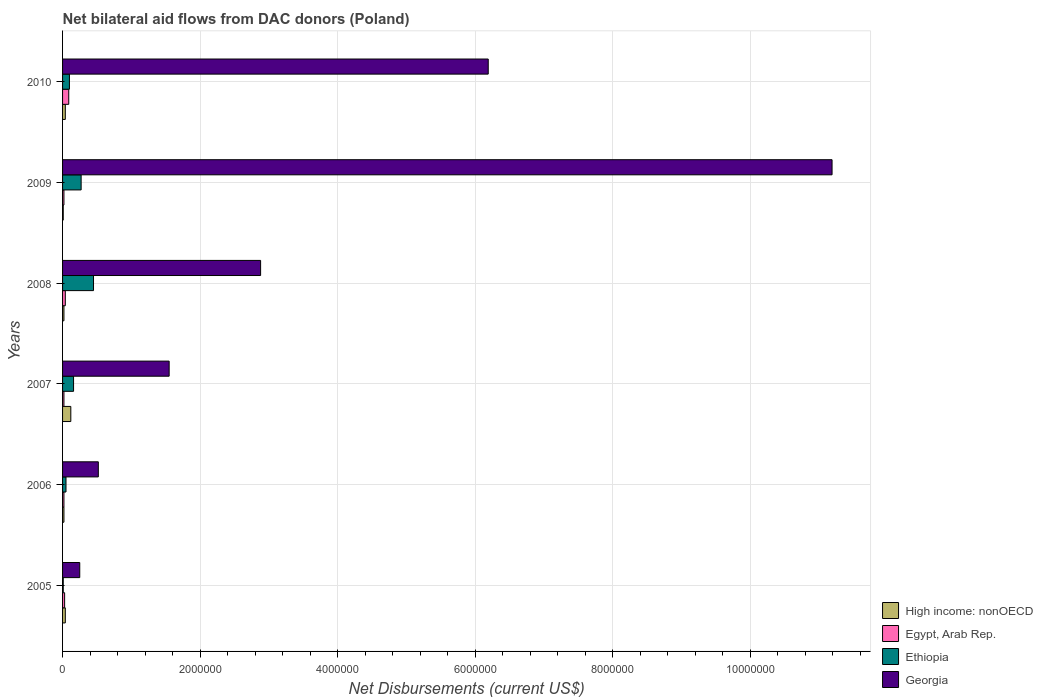How many different coloured bars are there?
Provide a short and direct response. 4. How many groups of bars are there?
Your answer should be very brief. 6. Are the number of bars on each tick of the Y-axis equal?
Your answer should be very brief. Yes. How many bars are there on the 1st tick from the bottom?
Provide a short and direct response. 4. What is the net bilateral aid flows in High income: nonOECD in 2007?
Provide a succinct answer. 1.20e+05. Across all years, what is the maximum net bilateral aid flows in Egypt, Arab Rep.?
Provide a succinct answer. 9.00e+04. Across all years, what is the minimum net bilateral aid flows in Egypt, Arab Rep.?
Offer a very short reply. 2.00e+04. In which year was the net bilateral aid flows in Egypt, Arab Rep. maximum?
Provide a short and direct response. 2010. What is the total net bilateral aid flows in High income: nonOECD in the graph?
Ensure brevity in your answer.  2.50e+05. What is the difference between the net bilateral aid flows in High income: nonOECD in 2009 and the net bilateral aid flows in Georgia in 2007?
Give a very brief answer. -1.54e+06. What is the average net bilateral aid flows in Ethiopia per year?
Ensure brevity in your answer.  1.73e+05. In the year 2009, what is the difference between the net bilateral aid flows in Ethiopia and net bilateral aid flows in High income: nonOECD?
Provide a succinct answer. 2.60e+05. What is the ratio of the net bilateral aid flows in Egypt, Arab Rep. in 2005 to that in 2007?
Your response must be concise. 1.5. What is the difference between the highest and the lowest net bilateral aid flows in Georgia?
Provide a short and direct response. 1.09e+07. In how many years, is the net bilateral aid flows in Georgia greater than the average net bilateral aid flows in Georgia taken over all years?
Offer a terse response. 2. Is it the case that in every year, the sum of the net bilateral aid flows in Ethiopia and net bilateral aid flows in Georgia is greater than the sum of net bilateral aid flows in Egypt, Arab Rep. and net bilateral aid flows in High income: nonOECD?
Your answer should be compact. Yes. What does the 1st bar from the top in 2007 represents?
Keep it short and to the point. Georgia. What does the 4th bar from the bottom in 2010 represents?
Offer a terse response. Georgia. How many bars are there?
Your answer should be very brief. 24. Are all the bars in the graph horizontal?
Your answer should be very brief. Yes. Are the values on the major ticks of X-axis written in scientific E-notation?
Your answer should be compact. No. Does the graph contain any zero values?
Give a very brief answer. No. Does the graph contain grids?
Make the answer very short. Yes. What is the title of the graph?
Keep it short and to the point. Net bilateral aid flows from DAC donors (Poland). Does "Faeroe Islands" appear as one of the legend labels in the graph?
Your answer should be compact. No. What is the label or title of the X-axis?
Make the answer very short. Net Disbursements (current US$). What is the label or title of the Y-axis?
Offer a very short reply. Years. What is the Net Disbursements (current US$) in Georgia in 2005?
Give a very brief answer. 2.50e+05. What is the Net Disbursements (current US$) in High income: nonOECD in 2006?
Your answer should be very brief. 2.00e+04. What is the Net Disbursements (current US$) of Ethiopia in 2006?
Keep it short and to the point. 5.00e+04. What is the Net Disbursements (current US$) of Georgia in 2006?
Give a very brief answer. 5.20e+05. What is the Net Disbursements (current US$) of High income: nonOECD in 2007?
Provide a succinct answer. 1.20e+05. What is the Net Disbursements (current US$) in Ethiopia in 2007?
Provide a succinct answer. 1.60e+05. What is the Net Disbursements (current US$) in Georgia in 2007?
Offer a terse response. 1.55e+06. What is the Net Disbursements (current US$) in Ethiopia in 2008?
Your response must be concise. 4.50e+05. What is the Net Disbursements (current US$) in Georgia in 2008?
Keep it short and to the point. 2.88e+06. What is the Net Disbursements (current US$) of High income: nonOECD in 2009?
Your answer should be very brief. 10000. What is the Net Disbursements (current US$) of Egypt, Arab Rep. in 2009?
Your response must be concise. 2.00e+04. What is the Net Disbursements (current US$) in Georgia in 2009?
Your answer should be very brief. 1.12e+07. What is the Net Disbursements (current US$) of Ethiopia in 2010?
Provide a short and direct response. 1.00e+05. What is the Net Disbursements (current US$) in Georgia in 2010?
Ensure brevity in your answer.  6.19e+06. Across all years, what is the maximum Net Disbursements (current US$) of Egypt, Arab Rep.?
Your answer should be compact. 9.00e+04. Across all years, what is the maximum Net Disbursements (current US$) of Georgia?
Provide a short and direct response. 1.12e+07. Across all years, what is the minimum Net Disbursements (current US$) of High income: nonOECD?
Offer a very short reply. 10000. Across all years, what is the minimum Net Disbursements (current US$) in Ethiopia?
Your answer should be very brief. 10000. Across all years, what is the minimum Net Disbursements (current US$) in Georgia?
Ensure brevity in your answer.  2.50e+05. What is the total Net Disbursements (current US$) of High income: nonOECD in the graph?
Provide a short and direct response. 2.50e+05. What is the total Net Disbursements (current US$) of Egypt, Arab Rep. in the graph?
Your response must be concise. 2.20e+05. What is the total Net Disbursements (current US$) of Ethiopia in the graph?
Make the answer very short. 1.04e+06. What is the total Net Disbursements (current US$) in Georgia in the graph?
Offer a very short reply. 2.26e+07. What is the difference between the Net Disbursements (current US$) of High income: nonOECD in 2005 and that in 2006?
Keep it short and to the point. 2.00e+04. What is the difference between the Net Disbursements (current US$) of Georgia in 2005 and that in 2006?
Give a very brief answer. -2.70e+05. What is the difference between the Net Disbursements (current US$) in High income: nonOECD in 2005 and that in 2007?
Give a very brief answer. -8.00e+04. What is the difference between the Net Disbursements (current US$) of Egypt, Arab Rep. in 2005 and that in 2007?
Provide a succinct answer. 10000. What is the difference between the Net Disbursements (current US$) in Georgia in 2005 and that in 2007?
Ensure brevity in your answer.  -1.30e+06. What is the difference between the Net Disbursements (current US$) of High income: nonOECD in 2005 and that in 2008?
Keep it short and to the point. 2.00e+04. What is the difference between the Net Disbursements (current US$) of Egypt, Arab Rep. in 2005 and that in 2008?
Your answer should be very brief. -10000. What is the difference between the Net Disbursements (current US$) of Ethiopia in 2005 and that in 2008?
Your answer should be very brief. -4.40e+05. What is the difference between the Net Disbursements (current US$) of Georgia in 2005 and that in 2008?
Make the answer very short. -2.63e+06. What is the difference between the Net Disbursements (current US$) in Ethiopia in 2005 and that in 2009?
Offer a terse response. -2.60e+05. What is the difference between the Net Disbursements (current US$) of Georgia in 2005 and that in 2009?
Offer a very short reply. -1.09e+07. What is the difference between the Net Disbursements (current US$) in High income: nonOECD in 2005 and that in 2010?
Your answer should be compact. 0. What is the difference between the Net Disbursements (current US$) in Georgia in 2005 and that in 2010?
Your answer should be compact. -5.94e+06. What is the difference between the Net Disbursements (current US$) in Georgia in 2006 and that in 2007?
Offer a very short reply. -1.03e+06. What is the difference between the Net Disbursements (current US$) of Ethiopia in 2006 and that in 2008?
Offer a terse response. -4.00e+05. What is the difference between the Net Disbursements (current US$) in Georgia in 2006 and that in 2008?
Your answer should be very brief. -2.36e+06. What is the difference between the Net Disbursements (current US$) in Egypt, Arab Rep. in 2006 and that in 2009?
Your answer should be compact. 0. What is the difference between the Net Disbursements (current US$) of Georgia in 2006 and that in 2009?
Ensure brevity in your answer.  -1.07e+07. What is the difference between the Net Disbursements (current US$) of Ethiopia in 2006 and that in 2010?
Provide a succinct answer. -5.00e+04. What is the difference between the Net Disbursements (current US$) in Georgia in 2006 and that in 2010?
Offer a very short reply. -5.67e+06. What is the difference between the Net Disbursements (current US$) in High income: nonOECD in 2007 and that in 2008?
Keep it short and to the point. 1.00e+05. What is the difference between the Net Disbursements (current US$) in Georgia in 2007 and that in 2008?
Ensure brevity in your answer.  -1.33e+06. What is the difference between the Net Disbursements (current US$) of High income: nonOECD in 2007 and that in 2009?
Offer a terse response. 1.10e+05. What is the difference between the Net Disbursements (current US$) of Egypt, Arab Rep. in 2007 and that in 2009?
Your answer should be very brief. 0. What is the difference between the Net Disbursements (current US$) in Ethiopia in 2007 and that in 2009?
Provide a short and direct response. -1.10e+05. What is the difference between the Net Disbursements (current US$) in Georgia in 2007 and that in 2009?
Ensure brevity in your answer.  -9.64e+06. What is the difference between the Net Disbursements (current US$) in High income: nonOECD in 2007 and that in 2010?
Your answer should be compact. 8.00e+04. What is the difference between the Net Disbursements (current US$) of Egypt, Arab Rep. in 2007 and that in 2010?
Keep it short and to the point. -7.00e+04. What is the difference between the Net Disbursements (current US$) in Georgia in 2007 and that in 2010?
Your response must be concise. -4.64e+06. What is the difference between the Net Disbursements (current US$) in Ethiopia in 2008 and that in 2009?
Your answer should be very brief. 1.80e+05. What is the difference between the Net Disbursements (current US$) of Georgia in 2008 and that in 2009?
Your answer should be compact. -8.31e+06. What is the difference between the Net Disbursements (current US$) of High income: nonOECD in 2008 and that in 2010?
Make the answer very short. -2.00e+04. What is the difference between the Net Disbursements (current US$) of Egypt, Arab Rep. in 2008 and that in 2010?
Your response must be concise. -5.00e+04. What is the difference between the Net Disbursements (current US$) in Ethiopia in 2008 and that in 2010?
Offer a terse response. 3.50e+05. What is the difference between the Net Disbursements (current US$) in Georgia in 2008 and that in 2010?
Give a very brief answer. -3.31e+06. What is the difference between the Net Disbursements (current US$) in Ethiopia in 2009 and that in 2010?
Your answer should be very brief. 1.70e+05. What is the difference between the Net Disbursements (current US$) of High income: nonOECD in 2005 and the Net Disbursements (current US$) of Ethiopia in 2006?
Offer a very short reply. -10000. What is the difference between the Net Disbursements (current US$) in High income: nonOECD in 2005 and the Net Disbursements (current US$) in Georgia in 2006?
Provide a short and direct response. -4.80e+05. What is the difference between the Net Disbursements (current US$) in Egypt, Arab Rep. in 2005 and the Net Disbursements (current US$) in Georgia in 2006?
Offer a very short reply. -4.90e+05. What is the difference between the Net Disbursements (current US$) in Ethiopia in 2005 and the Net Disbursements (current US$) in Georgia in 2006?
Your response must be concise. -5.10e+05. What is the difference between the Net Disbursements (current US$) of High income: nonOECD in 2005 and the Net Disbursements (current US$) of Egypt, Arab Rep. in 2007?
Your answer should be very brief. 2.00e+04. What is the difference between the Net Disbursements (current US$) of High income: nonOECD in 2005 and the Net Disbursements (current US$) of Georgia in 2007?
Your answer should be compact. -1.51e+06. What is the difference between the Net Disbursements (current US$) of Egypt, Arab Rep. in 2005 and the Net Disbursements (current US$) of Georgia in 2007?
Your response must be concise. -1.52e+06. What is the difference between the Net Disbursements (current US$) in Ethiopia in 2005 and the Net Disbursements (current US$) in Georgia in 2007?
Make the answer very short. -1.54e+06. What is the difference between the Net Disbursements (current US$) of High income: nonOECD in 2005 and the Net Disbursements (current US$) of Egypt, Arab Rep. in 2008?
Make the answer very short. 0. What is the difference between the Net Disbursements (current US$) of High income: nonOECD in 2005 and the Net Disbursements (current US$) of Ethiopia in 2008?
Your answer should be compact. -4.10e+05. What is the difference between the Net Disbursements (current US$) of High income: nonOECD in 2005 and the Net Disbursements (current US$) of Georgia in 2008?
Keep it short and to the point. -2.84e+06. What is the difference between the Net Disbursements (current US$) of Egypt, Arab Rep. in 2005 and the Net Disbursements (current US$) of Ethiopia in 2008?
Provide a short and direct response. -4.20e+05. What is the difference between the Net Disbursements (current US$) in Egypt, Arab Rep. in 2005 and the Net Disbursements (current US$) in Georgia in 2008?
Give a very brief answer. -2.85e+06. What is the difference between the Net Disbursements (current US$) in Ethiopia in 2005 and the Net Disbursements (current US$) in Georgia in 2008?
Your answer should be compact. -2.87e+06. What is the difference between the Net Disbursements (current US$) of High income: nonOECD in 2005 and the Net Disbursements (current US$) of Ethiopia in 2009?
Your response must be concise. -2.30e+05. What is the difference between the Net Disbursements (current US$) in High income: nonOECD in 2005 and the Net Disbursements (current US$) in Georgia in 2009?
Your response must be concise. -1.12e+07. What is the difference between the Net Disbursements (current US$) of Egypt, Arab Rep. in 2005 and the Net Disbursements (current US$) of Georgia in 2009?
Your answer should be compact. -1.12e+07. What is the difference between the Net Disbursements (current US$) in Ethiopia in 2005 and the Net Disbursements (current US$) in Georgia in 2009?
Your answer should be compact. -1.12e+07. What is the difference between the Net Disbursements (current US$) of High income: nonOECD in 2005 and the Net Disbursements (current US$) of Egypt, Arab Rep. in 2010?
Offer a very short reply. -5.00e+04. What is the difference between the Net Disbursements (current US$) of High income: nonOECD in 2005 and the Net Disbursements (current US$) of Ethiopia in 2010?
Provide a succinct answer. -6.00e+04. What is the difference between the Net Disbursements (current US$) of High income: nonOECD in 2005 and the Net Disbursements (current US$) of Georgia in 2010?
Keep it short and to the point. -6.15e+06. What is the difference between the Net Disbursements (current US$) of Egypt, Arab Rep. in 2005 and the Net Disbursements (current US$) of Ethiopia in 2010?
Provide a short and direct response. -7.00e+04. What is the difference between the Net Disbursements (current US$) in Egypt, Arab Rep. in 2005 and the Net Disbursements (current US$) in Georgia in 2010?
Keep it short and to the point. -6.16e+06. What is the difference between the Net Disbursements (current US$) in Ethiopia in 2005 and the Net Disbursements (current US$) in Georgia in 2010?
Give a very brief answer. -6.18e+06. What is the difference between the Net Disbursements (current US$) of High income: nonOECD in 2006 and the Net Disbursements (current US$) of Egypt, Arab Rep. in 2007?
Make the answer very short. 0. What is the difference between the Net Disbursements (current US$) of High income: nonOECD in 2006 and the Net Disbursements (current US$) of Ethiopia in 2007?
Offer a terse response. -1.40e+05. What is the difference between the Net Disbursements (current US$) in High income: nonOECD in 2006 and the Net Disbursements (current US$) in Georgia in 2007?
Offer a terse response. -1.53e+06. What is the difference between the Net Disbursements (current US$) of Egypt, Arab Rep. in 2006 and the Net Disbursements (current US$) of Ethiopia in 2007?
Offer a very short reply. -1.40e+05. What is the difference between the Net Disbursements (current US$) in Egypt, Arab Rep. in 2006 and the Net Disbursements (current US$) in Georgia in 2007?
Your answer should be compact. -1.53e+06. What is the difference between the Net Disbursements (current US$) of Ethiopia in 2006 and the Net Disbursements (current US$) of Georgia in 2007?
Your response must be concise. -1.50e+06. What is the difference between the Net Disbursements (current US$) of High income: nonOECD in 2006 and the Net Disbursements (current US$) of Ethiopia in 2008?
Your answer should be very brief. -4.30e+05. What is the difference between the Net Disbursements (current US$) of High income: nonOECD in 2006 and the Net Disbursements (current US$) of Georgia in 2008?
Give a very brief answer. -2.86e+06. What is the difference between the Net Disbursements (current US$) in Egypt, Arab Rep. in 2006 and the Net Disbursements (current US$) in Ethiopia in 2008?
Give a very brief answer. -4.30e+05. What is the difference between the Net Disbursements (current US$) in Egypt, Arab Rep. in 2006 and the Net Disbursements (current US$) in Georgia in 2008?
Give a very brief answer. -2.86e+06. What is the difference between the Net Disbursements (current US$) in Ethiopia in 2006 and the Net Disbursements (current US$) in Georgia in 2008?
Give a very brief answer. -2.83e+06. What is the difference between the Net Disbursements (current US$) of High income: nonOECD in 2006 and the Net Disbursements (current US$) of Egypt, Arab Rep. in 2009?
Your answer should be compact. 0. What is the difference between the Net Disbursements (current US$) in High income: nonOECD in 2006 and the Net Disbursements (current US$) in Georgia in 2009?
Offer a very short reply. -1.12e+07. What is the difference between the Net Disbursements (current US$) of Egypt, Arab Rep. in 2006 and the Net Disbursements (current US$) of Ethiopia in 2009?
Provide a succinct answer. -2.50e+05. What is the difference between the Net Disbursements (current US$) in Egypt, Arab Rep. in 2006 and the Net Disbursements (current US$) in Georgia in 2009?
Your response must be concise. -1.12e+07. What is the difference between the Net Disbursements (current US$) of Ethiopia in 2006 and the Net Disbursements (current US$) of Georgia in 2009?
Provide a succinct answer. -1.11e+07. What is the difference between the Net Disbursements (current US$) of High income: nonOECD in 2006 and the Net Disbursements (current US$) of Egypt, Arab Rep. in 2010?
Offer a terse response. -7.00e+04. What is the difference between the Net Disbursements (current US$) of High income: nonOECD in 2006 and the Net Disbursements (current US$) of Georgia in 2010?
Your answer should be very brief. -6.17e+06. What is the difference between the Net Disbursements (current US$) of Egypt, Arab Rep. in 2006 and the Net Disbursements (current US$) of Georgia in 2010?
Keep it short and to the point. -6.17e+06. What is the difference between the Net Disbursements (current US$) of Ethiopia in 2006 and the Net Disbursements (current US$) of Georgia in 2010?
Offer a terse response. -6.14e+06. What is the difference between the Net Disbursements (current US$) in High income: nonOECD in 2007 and the Net Disbursements (current US$) in Ethiopia in 2008?
Provide a succinct answer. -3.30e+05. What is the difference between the Net Disbursements (current US$) in High income: nonOECD in 2007 and the Net Disbursements (current US$) in Georgia in 2008?
Your answer should be very brief. -2.76e+06. What is the difference between the Net Disbursements (current US$) in Egypt, Arab Rep. in 2007 and the Net Disbursements (current US$) in Ethiopia in 2008?
Make the answer very short. -4.30e+05. What is the difference between the Net Disbursements (current US$) of Egypt, Arab Rep. in 2007 and the Net Disbursements (current US$) of Georgia in 2008?
Offer a terse response. -2.86e+06. What is the difference between the Net Disbursements (current US$) of Ethiopia in 2007 and the Net Disbursements (current US$) of Georgia in 2008?
Your answer should be compact. -2.72e+06. What is the difference between the Net Disbursements (current US$) in High income: nonOECD in 2007 and the Net Disbursements (current US$) in Georgia in 2009?
Provide a short and direct response. -1.11e+07. What is the difference between the Net Disbursements (current US$) of Egypt, Arab Rep. in 2007 and the Net Disbursements (current US$) of Ethiopia in 2009?
Give a very brief answer. -2.50e+05. What is the difference between the Net Disbursements (current US$) in Egypt, Arab Rep. in 2007 and the Net Disbursements (current US$) in Georgia in 2009?
Provide a succinct answer. -1.12e+07. What is the difference between the Net Disbursements (current US$) in Ethiopia in 2007 and the Net Disbursements (current US$) in Georgia in 2009?
Provide a succinct answer. -1.10e+07. What is the difference between the Net Disbursements (current US$) of High income: nonOECD in 2007 and the Net Disbursements (current US$) of Georgia in 2010?
Offer a very short reply. -6.07e+06. What is the difference between the Net Disbursements (current US$) in Egypt, Arab Rep. in 2007 and the Net Disbursements (current US$) in Georgia in 2010?
Your response must be concise. -6.17e+06. What is the difference between the Net Disbursements (current US$) of Ethiopia in 2007 and the Net Disbursements (current US$) of Georgia in 2010?
Your response must be concise. -6.03e+06. What is the difference between the Net Disbursements (current US$) of High income: nonOECD in 2008 and the Net Disbursements (current US$) of Ethiopia in 2009?
Give a very brief answer. -2.50e+05. What is the difference between the Net Disbursements (current US$) of High income: nonOECD in 2008 and the Net Disbursements (current US$) of Georgia in 2009?
Your answer should be compact. -1.12e+07. What is the difference between the Net Disbursements (current US$) in Egypt, Arab Rep. in 2008 and the Net Disbursements (current US$) in Georgia in 2009?
Your response must be concise. -1.12e+07. What is the difference between the Net Disbursements (current US$) of Ethiopia in 2008 and the Net Disbursements (current US$) of Georgia in 2009?
Make the answer very short. -1.07e+07. What is the difference between the Net Disbursements (current US$) of High income: nonOECD in 2008 and the Net Disbursements (current US$) of Egypt, Arab Rep. in 2010?
Keep it short and to the point. -7.00e+04. What is the difference between the Net Disbursements (current US$) of High income: nonOECD in 2008 and the Net Disbursements (current US$) of Georgia in 2010?
Your answer should be compact. -6.17e+06. What is the difference between the Net Disbursements (current US$) in Egypt, Arab Rep. in 2008 and the Net Disbursements (current US$) in Georgia in 2010?
Make the answer very short. -6.15e+06. What is the difference between the Net Disbursements (current US$) in Ethiopia in 2008 and the Net Disbursements (current US$) in Georgia in 2010?
Give a very brief answer. -5.74e+06. What is the difference between the Net Disbursements (current US$) in High income: nonOECD in 2009 and the Net Disbursements (current US$) in Egypt, Arab Rep. in 2010?
Your response must be concise. -8.00e+04. What is the difference between the Net Disbursements (current US$) of High income: nonOECD in 2009 and the Net Disbursements (current US$) of Georgia in 2010?
Keep it short and to the point. -6.18e+06. What is the difference between the Net Disbursements (current US$) in Egypt, Arab Rep. in 2009 and the Net Disbursements (current US$) in Ethiopia in 2010?
Your response must be concise. -8.00e+04. What is the difference between the Net Disbursements (current US$) of Egypt, Arab Rep. in 2009 and the Net Disbursements (current US$) of Georgia in 2010?
Make the answer very short. -6.17e+06. What is the difference between the Net Disbursements (current US$) of Ethiopia in 2009 and the Net Disbursements (current US$) of Georgia in 2010?
Provide a short and direct response. -5.92e+06. What is the average Net Disbursements (current US$) in High income: nonOECD per year?
Provide a succinct answer. 4.17e+04. What is the average Net Disbursements (current US$) of Egypt, Arab Rep. per year?
Ensure brevity in your answer.  3.67e+04. What is the average Net Disbursements (current US$) of Ethiopia per year?
Make the answer very short. 1.73e+05. What is the average Net Disbursements (current US$) of Georgia per year?
Offer a terse response. 3.76e+06. In the year 2005, what is the difference between the Net Disbursements (current US$) in High income: nonOECD and Net Disbursements (current US$) in Egypt, Arab Rep.?
Provide a succinct answer. 10000. In the year 2005, what is the difference between the Net Disbursements (current US$) in Egypt, Arab Rep. and Net Disbursements (current US$) in Ethiopia?
Your answer should be very brief. 2.00e+04. In the year 2006, what is the difference between the Net Disbursements (current US$) in High income: nonOECD and Net Disbursements (current US$) in Egypt, Arab Rep.?
Your response must be concise. 0. In the year 2006, what is the difference between the Net Disbursements (current US$) of High income: nonOECD and Net Disbursements (current US$) of Georgia?
Provide a succinct answer. -5.00e+05. In the year 2006, what is the difference between the Net Disbursements (current US$) in Egypt, Arab Rep. and Net Disbursements (current US$) in Georgia?
Make the answer very short. -5.00e+05. In the year 2006, what is the difference between the Net Disbursements (current US$) in Ethiopia and Net Disbursements (current US$) in Georgia?
Make the answer very short. -4.70e+05. In the year 2007, what is the difference between the Net Disbursements (current US$) of High income: nonOECD and Net Disbursements (current US$) of Egypt, Arab Rep.?
Your answer should be compact. 1.00e+05. In the year 2007, what is the difference between the Net Disbursements (current US$) of High income: nonOECD and Net Disbursements (current US$) of Ethiopia?
Your answer should be very brief. -4.00e+04. In the year 2007, what is the difference between the Net Disbursements (current US$) of High income: nonOECD and Net Disbursements (current US$) of Georgia?
Keep it short and to the point. -1.43e+06. In the year 2007, what is the difference between the Net Disbursements (current US$) of Egypt, Arab Rep. and Net Disbursements (current US$) of Georgia?
Provide a short and direct response. -1.53e+06. In the year 2007, what is the difference between the Net Disbursements (current US$) in Ethiopia and Net Disbursements (current US$) in Georgia?
Provide a short and direct response. -1.39e+06. In the year 2008, what is the difference between the Net Disbursements (current US$) in High income: nonOECD and Net Disbursements (current US$) in Egypt, Arab Rep.?
Keep it short and to the point. -2.00e+04. In the year 2008, what is the difference between the Net Disbursements (current US$) of High income: nonOECD and Net Disbursements (current US$) of Ethiopia?
Provide a short and direct response. -4.30e+05. In the year 2008, what is the difference between the Net Disbursements (current US$) of High income: nonOECD and Net Disbursements (current US$) of Georgia?
Provide a short and direct response. -2.86e+06. In the year 2008, what is the difference between the Net Disbursements (current US$) of Egypt, Arab Rep. and Net Disbursements (current US$) of Ethiopia?
Give a very brief answer. -4.10e+05. In the year 2008, what is the difference between the Net Disbursements (current US$) of Egypt, Arab Rep. and Net Disbursements (current US$) of Georgia?
Provide a short and direct response. -2.84e+06. In the year 2008, what is the difference between the Net Disbursements (current US$) of Ethiopia and Net Disbursements (current US$) of Georgia?
Keep it short and to the point. -2.43e+06. In the year 2009, what is the difference between the Net Disbursements (current US$) of High income: nonOECD and Net Disbursements (current US$) of Ethiopia?
Provide a short and direct response. -2.60e+05. In the year 2009, what is the difference between the Net Disbursements (current US$) in High income: nonOECD and Net Disbursements (current US$) in Georgia?
Your answer should be compact. -1.12e+07. In the year 2009, what is the difference between the Net Disbursements (current US$) of Egypt, Arab Rep. and Net Disbursements (current US$) of Ethiopia?
Give a very brief answer. -2.50e+05. In the year 2009, what is the difference between the Net Disbursements (current US$) in Egypt, Arab Rep. and Net Disbursements (current US$) in Georgia?
Offer a very short reply. -1.12e+07. In the year 2009, what is the difference between the Net Disbursements (current US$) in Ethiopia and Net Disbursements (current US$) in Georgia?
Give a very brief answer. -1.09e+07. In the year 2010, what is the difference between the Net Disbursements (current US$) in High income: nonOECD and Net Disbursements (current US$) in Egypt, Arab Rep.?
Make the answer very short. -5.00e+04. In the year 2010, what is the difference between the Net Disbursements (current US$) in High income: nonOECD and Net Disbursements (current US$) in Georgia?
Ensure brevity in your answer.  -6.15e+06. In the year 2010, what is the difference between the Net Disbursements (current US$) of Egypt, Arab Rep. and Net Disbursements (current US$) of Georgia?
Make the answer very short. -6.10e+06. In the year 2010, what is the difference between the Net Disbursements (current US$) of Ethiopia and Net Disbursements (current US$) of Georgia?
Offer a terse response. -6.09e+06. What is the ratio of the Net Disbursements (current US$) in High income: nonOECD in 2005 to that in 2006?
Offer a very short reply. 2. What is the ratio of the Net Disbursements (current US$) in Ethiopia in 2005 to that in 2006?
Ensure brevity in your answer.  0.2. What is the ratio of the Net Disbursements (current US$) in Georgia in 2005 to that in 2006?
Give a very brief answer. 0.48. What is the ratio of the Net Disbursements (current US$) of High income: nonOECD in 2005 to that in 2007?
Your answer should be compact. 0.33. What is the ratio of the Net Disbursements (current US$) in Ethiopia in 2005 to that in 2007?
Offer a terse response. 0.06. What is the ratio of the Net Disbursements (current US$) of Georgia in 2005 to that in 2007?
Your answer should be very brief. 0.16. What is the ratio of the Net Disbursements (current US$) of High income: nonOECD in 2005 to that in 2008?
Keep it short and to the point. 2. What is the ratio of the Net Disbursements (current US$) of Egypt, Arab Rep. in 2005 to that in 2008?
Offer a terse response. 0.75. What is the ratio of the Net Disbursements (current US$) in Ethiopia in 2005 to that in 2008?
Your answer should be very brief. 0.02. What is the ratio of the Net Disbursements (current US$) in Georgia in 2005 to that in 2008?
Provide a short and direct response. 0.09. What is the ratio of the Net Disbursements (current US$) of High income: nonOECD in 2005 to that in 2009?
Offer a very short reply. 4. What is the ratio of the Net Disbursements (current US$) in Egypt, Arab Rep. in 2005 to that in 2009?
Give a very brief answer. 1.5. What is the ratio of the Net Disbursements (current US$) in Ethiopia in 2005 to that in 2009?
Give a very brief answer. 0.04. What is the ratio of the Net Disbursements (current US$) in Georgia in 2005 to that in 2009?
Your response must be concise. 0.02. What is the ratio of the Net Disbursements (current US$) of High income: nonOECD in 2005 to that in 2010?
Keep it short and to the point. 1. What is the ratio of the Net Disbursements (current US$) of Egypt, Arab Rep. in 2005 to that in 2010?
Your answer should be compact. 0.33. What is the ratio of the Net Disbursements (current US$) in Ethiopia in 2005 to that in 2010?
Give a very brief answer. 0.1. What is the ratio of the Net Disbursements (current US$) in Georgia in 2005 to that in 2010?
Ensure brevity in your answer.  0.04. What is the ratio of the Net Disbursements (current US$) of Egypt, Arab Rep. in 2006 to that in 2007?
Your response must be concise. 1. What is the ratio of the Net Disbursements (current US$) in Ethiopia in 2006 to that in 2007?
Offer a terse response. 0.31. What is the ratio of the Net Disbursements (current US$) in Georgia in 2006 to that in 2007?
Keep it short and to the point. 0.34. What is the ratio of the Net Disbursements (current US$) in High income: nonOECD in 2006 to that in 2008?
Give a very brief answer. 1. What is the ratio of the Net Disbursements (current US$) of Egypt, Arab Rep. in 2006 to that in 2008?
Keep it short and to the point. 0.5. What is the ratio of the Net Disbursements (current US$) in Ethiopia in 2006 to that in 2008?
Make the answer very short. 0.11. What is the ratio of the Net Disbursements (current US$) in Georgia in 2006 to that in 2008?
Give a very brief answer. 0.18. What is the ratio of the Net Disbursements (current US$) in High income: nonOECD in 2006 to that in 2009?
Offer a very short reply. 2. What is the ratio of the Net Disbursements (current US$) of Ethiopia in 2006 to that in 2009?
Provide a succinct answer. 0.19. What is the ratio of the Net Disbursements (current US$) in Georgia in 2006 to that in 2009?
Ensure brevity in your answer.  0.05. What is the ratio of the Net Disbursements (current US$) of High income: nonOECD in 2006 to that in 2010?
Your answer should be very brief. 0.5. What is the ratio of the Net Disbursements (current US$) in Egypt, Arab Rep. in 2006 to that in 2010?
Provide a succinct answer. 0.22. What is the ratio of the Net Disbursements (current US$) in Georgia in 2006 to that in 2010?
Your answer should be compact. 0.08. What is the ratio of the Net Disbursements (current US$) of High income: nonOECD in 2007 to that in 2008?
Provide a succinct answer. 6. What is the ratio of the Net Disbursements (current US$) in Ethiopia in 2007 to that in 2008?
Keep it short and to the point. 0.36. What is the ratio of the Net Disbursements (current US$) in Georgia in 2007 to that in 2008?
Make the answer very short. 0.54. What is the ratio of the Net Disbursements (current US$) in High income: nonOECD in 2007 to that in 2009?
Your response must be concise. 12. What is the ratio of the Net Disbursements (current US$) of Ethiopia in 2007 to that in 2009?
Provide a short and direct response. 0.59. What is the ratio of the Net Disbursements (current US$) of Georgia in 2007 to that in 2009?
Provide a succinct answer. 0.14. What is the ratio of the Net Disbursements (current US$) of High income: nonOECD in 2007 to that in 2010?
Offer a very short reply. 3. What is the ratio of the Net Disbursements (current US$) of Egypt, Arab Rep. in 2007 to that in 2010?
Keep it short and to the point. 0.22. What is the ratio of the Net Disbursements (current US$) in Ethiopia in 2007 to that in 2010?
Provide a succinct answer. 1.6. What is the ratio of the Net Disbursements (current US$) in Georgia in 2007 to that in 2010?
Ensure brevity in your answer.  0.25. What is the ratio of the Net Disbursements (current US$) of Georgia in 2008 to that in 2009?
Your response must be concise. 0.26. What is the ratio of the Net Disbursements (current US$) in High income: nonOECD in 2008 to that in 2010?
Your response must be concise. 0.5. What is the ratio of the Net Disbursements (current US$) in Egypt, Arab Rep. in 2008 to that in 2010?
Your answer should be compact. 0.44. What is the ratio of the Net Disbursements (current US$) in Ethiopia in 2008 to that in 2010?
Your response must be concise. 4.5. What is the ratio of the Net Disbursements (current US$) in Georgia in 2008 to that in 2010?
Give a very brief answer. 0.47. What is the ratio of the Net Disbursements (current US$) in High income: nonOECD in 2009 to that in 2010?
Offer a very short reply. 0.25. What is the ratio of the Net Disbursements (current US$) in Egypt, Arab Rep. in 2009 to that in 2010?
Offer a very short reply. 0.22. What is the ratio of the Net Disbursements (current US$) of Georgia in 2009 to that in 2010?
Ensure brevity in your answer.  1.81. What is the difference between the highest and the lowest Net Disbursements (current US$) in Ethiopia?
Give a very brief answer. 4.40e+05. What is the difference between the highest and the lowest Net Disbursements (current US$) of Georgia?
Make the answer very short. 1.09e+07. 